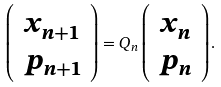Convert formula to latex. <formula><loc_0><loc_0><loc_500><loc_500>\left ( \begin{array} { c } x _ { n + 1 } \\ p _ { n + 1 } \\ \end{array} \right ) = { Q } _ { n } \left ( \begin{array} { c } x _ { n } \\ p _ { n } \\ \end{array} \right ) .</formula> 